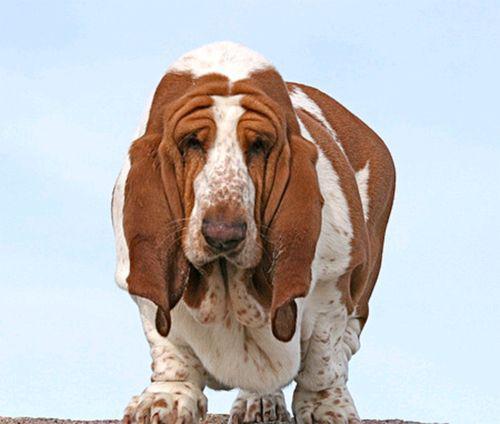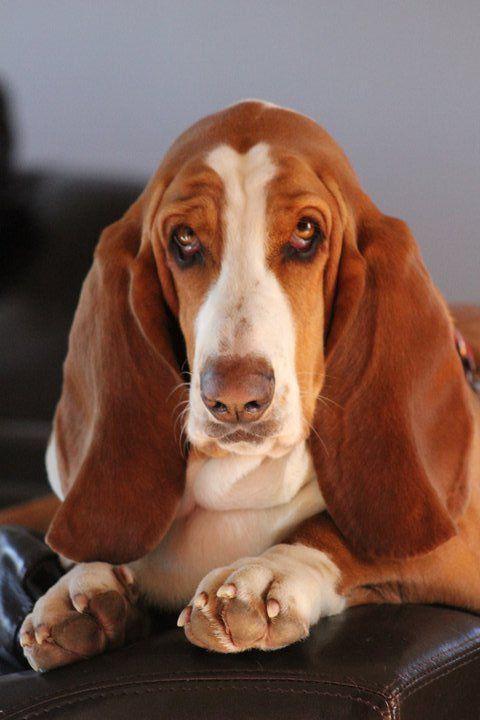The first image is the image on the left, the second image is the image on the right. Examine the images to the left and right. Is the description "One image shows a forward-facing hound posed indoors wearing some type of outfit that includes a scarf." accurate? Answer yes or no. No. The first image is the image on the left, the second image is the image on the right. Given the left and right images, does the statement "One of the dogs is wearing an item of clothing." hold true? Answer yes or no. No. 